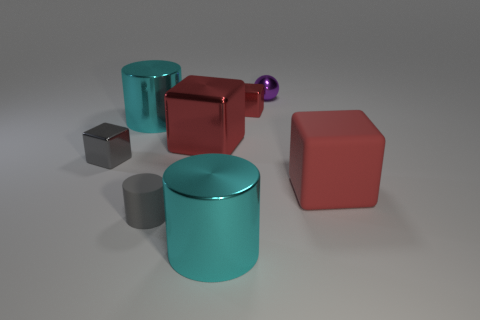How many red cubes must be subtracted to get 1 red cubes? 2 Subtract all yellow cylinders. How many red blocks are left? 3 Subtract 1 blocks. How many blocks are left? 3 Add 2 purple metal balls. How many objects exist? 10 Subtract all balls. How many objects are left? 7 Subtract all small shiny objects. Subtract all small yellow objects. How many objects are left? 5 Add 4 small purple shiny balls. How many small purple shiny balls are left? 5 Add 6 large cylinders. How many large cylinders exist? 8 Subtract 0 red balls. How many objects are left? 8 